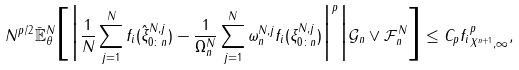<formula> <loc_0><loc_0><loc_500><loc_500>N ^ { p / 2 } \bar { \mathbb { E } } ^ { N } _ { \theta } \Big [ \Big | \frac { 1 } { N } \sum _ { j = 1 } ^ { N } f _ { i } ( \hat { \xi } _ { 0 \colon n } ^ { N , j } ) - \frac { 1 } { \Omega _ { n } ^ { N } } \sum _ { j = 1 } ^ { N } \omega _ { n } ^ { N , j } f _ { i } ( \xi _ { 0 \colon n } ^ { N , j } ) \Big | ^ { p } \Big | \mathcal { G } _ { n } \vee \mathcal { F } _ { n } ^ { N } \Big ] \leq C _ { p } \| f _ { i } \| _ { X ^ { n + 1 } , \infty } ^ { p } ,</formula> 